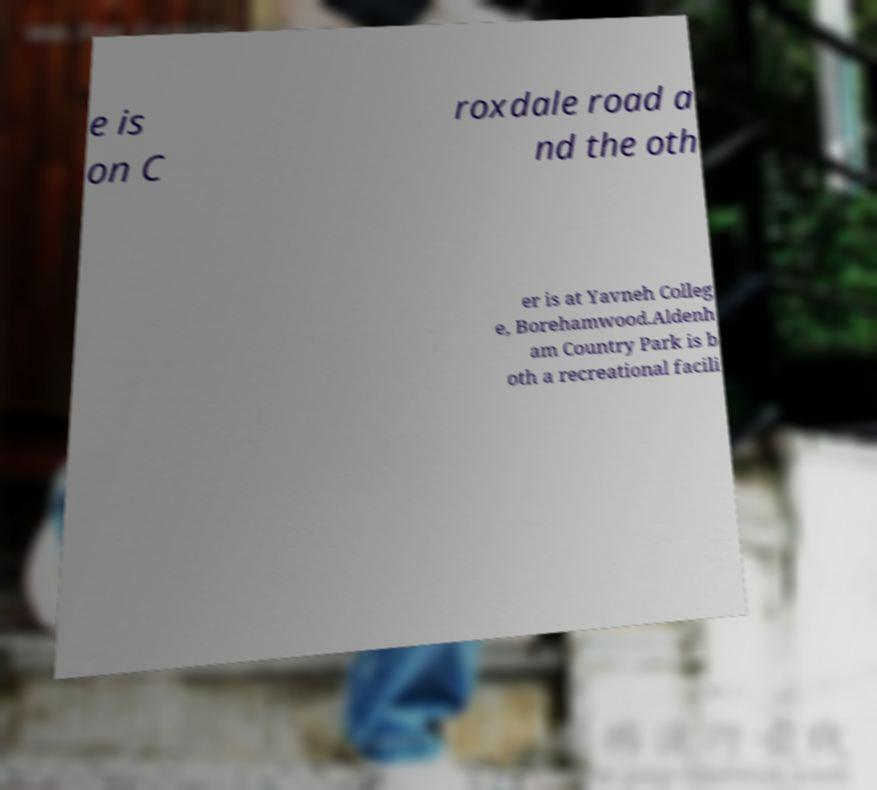Could you assist in decoding the text presented in this image and type it out clearly? e is on C roxdale road a nd the oth er is at Yavneh Colleg e, Borehamwood.Aldenh am Country Park is b oth a recreational facili 